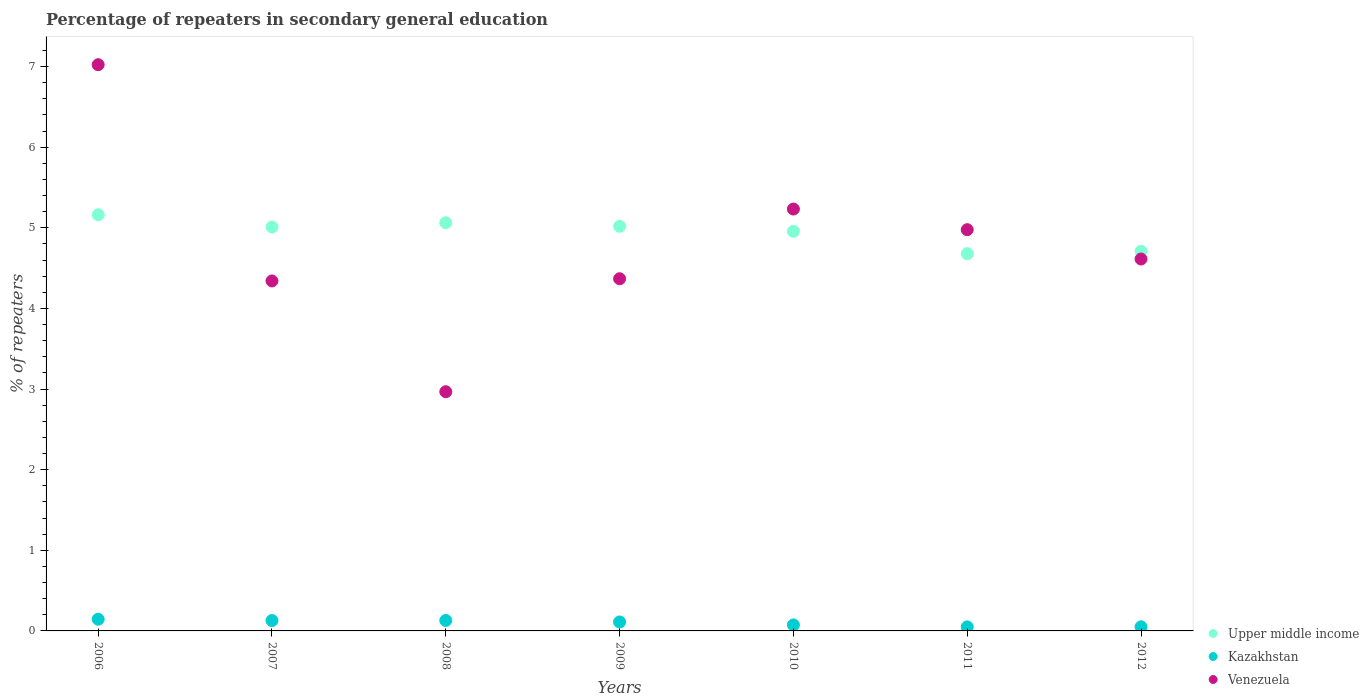Is the number of dotlines equal to the number of legend labels?
Your answer should be compact. Yes. What is the percentage of repeaters in secondary general education in Kazakhstan in 2007?
Ensure brevity in your answer.  0.13. Across all years, what is the maximum percentage of repeaters in secondary general education in Upper middle income?
Offer a very short reply. 5.16. Across all years, what is the minimum percentage of repeaters in secondary general education in Kazakhstan?
Offer a very short reply. 0.05. In which year was the percentage of repeaters in secondary general education in Upper middle income minimum?
Keep it short and to the point. 2011. What is the total percentage of repeaters in secondary general education in Upper middle income in the graph?
Your answer should be very brief. 34.6. What is the difference between the percentage of repeaters in secondary general education in Upper middle income in 2008 and that in 2009?
Offer a very short reply. 0.04. What is the difference between the percentage of repeaters in secondary general education in Venezuela in 2006 and the percentage of repeaters in secondary general education in Upper middle income in 2010?
Offer a terse response. 2.07. What is the average percentage of repeaters in secondary general education in Kazakhstan per year?
Make the answer very short. 0.1. In the year 2006, what is the difference between the percentage of repeaters in secondary general education in Upper middle income and percentage of repeaters in secondary general education in Venezuela?
Your answer should be very brief. -1.86. What is the ratio of the percentage of repeaters in secondary general education in Venezuela in 2009 to that in 2011?
Offer a very short reply. 0.88. What is the difference between the highest and the second highest percentage of repeaters in secondary general education in Venezuela?
Provide a short and direct response. 1.79. What is the difference between the highest and the lowest percentage of repeaters in secondary general education in Upper middle income?
Offer a very short reply. 0.48. In how many years, is the percentage of repeaters in secondary general education in Kazakhstan greater than the average percentage of repeaters in secondary general education in Kazakhstan taken over all years?
Provide a short and direct response. 4. Is it the case that in every year, the sum of the percentage of repeaters in secondary general education in Kazakhstan and percentage of repeaters in secondary general education in Venezuela  is greater than the percentage of repeaters in secondary general education in Upper middle income?
Offer a terse response. No. Is the percentage of repeaters in secondary general education in Venezuela strictly less than the percentage of repeaters in secondary general education in Kazakhstan over the years?
Your answer should be very brief. No. How many dotlines are there?
Ensure brevity in your answer.  3. How many years are there in the graph?
Your answer should be compact. 7. Are the values on the major ticks of Y-axis written in scientific E-notation?
Provide a succinct answer. No. How many legend labels are there?
Your answer should be very brief. 3. How are the legend labels stacked?
Offer a terse response. Vertical. What is the title of the graph?
Make the answer very short. Percentage of repeaters in secondary general education. Does "Marshall Islands" appear as one of the legend labels in the graph?
Make the answer very short. No. What is the label or title of the Y-axis?
Ensure brevity in your answer.  % of repeaters. What is the % of repeaters in Upper middle income in 2006?
Your response must be concise. 5.16. What is the % of repeaters of Kazakhstan in 2006?
Provide a short and direct response. 0.14. What is the % of repeaters in Venezuela in 2006?
Offer a very short reply. 7.02. What is the % of repeaters of Upper middle income in 2007?
Give a very brief answer. 5.01. What is the % of repeaters in Kazakhstan in 2007?
Provide a succinct answer. 0.13. What is the % of repeaters in Venezuela in 2007?
Your response must be concise. 4.34. What is the % of repeaters of Upper middle income in 2008?
Make the answer very short. 5.06. What is the % of repeaters in Kazakhstan in 2008?
Offer a terse response. 0.13. What is the % of repeaters of Venezuela in 2008?
Your response must be concise. 2.97. What is the % of repeaters of Upper middle income in 2009?
Offer a very short reply. 5.02. What is the % of repeaters of Kazakhstan in 2009?
Give a very brief answer. 0.11. What is the % of repeaters of Venezuela in 2009?
Keep it short and to the point. 4.37. What is the % of repeaters in Upper middle income in 2010?
Keep it short and to the point. 4.96. What is the % of repeaters in Kazakhstan in 2010?
Provide a succinct answer. 0.07. What is the % of repeaters in Venezuela in 2010?
Your response must be concise. 5.23. What is the % of repeaters in Upper middle income in 2011?
Ensure brevity in your answer.  4.68. What is the % of repeaters in Kazakhstan in 2011?
Give a very brief answer. 0.05. What is the % of repeaters in Venezuela in 2011?
Keep it short and to the point. 4.98. What is the % of repeaters of Upper middle income in 2012?
Offer a terse response. 4.71. What is the % of repeaters of Kazakhstan in 2012?
Offer a very short reply. 0.05. What is the % of repeaters in Venezuela in 2012?
Your answer should be compact. 4.61. Across all years, what is the maximum % of repeaters of Upper middle income?
Provide a short and direct response. 5.16. Across all years, what is the maximum % of repeaters in Kazakhstan?
Give a very brief answer. 0.14. Across all years, what is the maximum % of repeaters of Venezuela?
Give a very brief answer. 7.02. Across all years, what is the minimum % of repeaters of Upper middle income?
Provide a succinct answer. 4.68. Across all years, what is the minimum % of repeaters of Kazakhstan?
Offer a terse response. 0.05. Across all years, what is the minimum % of repeaters of Venezuela?
Offer a very short reply. 2.97. What is the total % of repeaters of Upper middle income in the graph?
Offer a terse response. 34.6. What is the total % of repeaters in Kazakhstan in the graph?
Ensure brevity in your answer.  0.69. What is the total % of repeaters in Venezuela in the graph?
Keep it short and to the point. 33.52. What is the difference between the % of repeaters in Upper middle income in 2006 and that in 2007?
Provide a short and direct response. 0.15. What is the difference between the % of repeaters in Kazakhstan in 2006 and that in 2007?
Offer a very short reply. 0.02. What is the difference between the % of repeaters of Venezuela in 2006 and that in 2007?
Your answer should be very brief. 2.68. What is the difference between the % of repeaters in Upper middle income in 2006 and that in 2008?
Provide a short and direct response. 0.1. What is the difference between the % of repeaters of Kazakhstan in 2006 and that in 2008?
Your answer should be compact. 0.02. What is the difference between the % of repeaters in Venezuela in 2006 and that in 2008?
Offer a very short reply. 4.06. What is the difference between the % of repeaters of Upper middle income in 2006 and that in 2009?
Make the answer very short. 0.14. What is the difference between the % of repeaters in Kazakhstan in 2006 and that in 2009?
Ensure brevity in your answer.  0.03. What is the difference between the % of repeaters in Venezuela in 2006 and that in 2009?
Provide a succinct answer. 2.66. What is the difference between the % of repeaters of Upper middle income in 2006 and that in 2010?
Your answer should be very brief. 0.21. What is the difference between the % of repeaters in Kazakhstan in 2006 and that in 2010?
Your response must be concise. 0.07. What is the difference between the % of repeaters of Venezuela in 2006 and that in 2010?
Your answer should be very brief. 1.79. What is the difference between the % of repeaters in Upper middle income in 2006 and that in 2011?
Your answer should be very brief. 0.48. What is the difference between the % of repeaters of Kazakhstan in 2006 and that in 2011?
Your answer should be very brief. 0.09. What is the difference between the % of repeaters of Venezuela in 2006 and that in 2011?
Offer a very short reply. 2.05. What is the difference between the % of repeaters of Upper middle income in 2006 and that in 2012?
Give a very brief answer. 0.45. What is the difference between the % of repeaters of Kazakhstan in 2006 and that in 2012?
Give a very brief answer. 0.09. What is the difference between the % of repeaters in Venezuela in 2006 and that in 2012?
Ensure brevity in your answer.  2.41. What is the difference between the % of repeaters in Upper middle income in 2007 and that in 2008?
Provide a short and direct response. -0.05. What is the difference between the % of repeaters of Kazakhstan in 2007 and that in 2008?
Give a very brief answer. -0. What is the difference between the % of repeaters of Venezuela in 2007 and that in 2008?
Keep it short and to the point. 1.37. What is the difference between the % of repeaters of Upper middle income in 2007 and that in 2009?
Keep it short and to the point. -0.01. What is the difference between the % of repeaters in Kazakhstan in 2007 and that in 2009?
Offer a very short reply. 0.02. What is the difference between the % of repeaters of Venezuela in 2007 and that in 2009?
Provide a succinct answer. -0.03. What is the difference between the % of repeaters in Upper middle income in 2007 and that in 2010?
Offer a very short reply. 0.05. What is the difference between the % of repeaters of Kazakhstan in 2007 and that in 2010?
Ensure brevity in your answer.  0.05. What is the difference between the % of repeaters of Venezuela in 2007 and that in 2010?
Offer a terse response. -0.89. What is the difference between the % of repeaters in Upper middle income in 2007 and that in 2011?
Keep it short and to the point. 0.33. What is the difference between the % of repeaters of Kazakhstan in 2007 and that in 2011?
Make the answer very short. 0.08. What is the difference between the % of repeaters in Venezuela in 2007 and that in 2011?
Provide a succinct answer. -0.64. What is the difference between the % of repeaters of Upper middle income in 2007 and that in 2012?
Ensure brevity in your answer.  0.3. What is the difference between the % of repeaters of Kazakhstan in 2007 and that in 2012?
Your answer should be compact. 0.08. What is the difference between the % of repeaters in Venezuela in 2007 and that in 2012?
Your answer should be compact. -0.27. What is the difference between the % of repeaters in Upper middle income in 2008 and that in 2009?
Your answer should be compact. 0.04. What is the difference between the % of repeaters in Kazakhstan in 2008 and that in 2009?
Offer a very short reply. 0.02. What is the difference between the % of repeaters of Venezuela in 2008 and that in 2009?
Give a very brief answer. -1.4. What is the difference between the % of repeaters of Upper middle income in 2008 and that in 2010?
Provide a short and direct response. 0.11. What is the difference between the % of repeaters of Kazakhstan in 2008 and that in 2010?
Provide a succinct answer. 0.06. What is the difference between the % of repeaters of Venezuela in 2008 and that in 2010?
Keep it short and to the point. -2.27. What is the difference between the % of repeaters of Upper middle income in 2008 and that in 2011?
Your response must be concise. 0.38. What is the difference between the % of repeaters in Kazakhstan in 2008 and that in 2011?
Offer a terse response. 0.08. What is the difference between the % of repeaters in Venezuela in 2008 and that in 2011?
Give a very brief answer. -2.01. What is the difference between the % of repeaters of Upper middle income in 2008 and that in 2012?
Provide a short and direct response. 0.35. What is the difference between the % of repeaters in Kazakhstan in 2008 and that in 2012?
Your response must be concise. 0.08. What is the difference between the % of repeaters of Venezuela in 2008 and that in 2012?
Your answer should be very brief. -1.65. What is the difference between the % of repeaters of Upper middle income in 2009 and that in 2010?
Offer a very short reply. 0.06. What is the difference between the % of repeaters of Kazakhstan in 2009 and that in 2010?
Offer a terse response. 0.04. What is the difference between the % of repeaters of Venezuela in 2009 and that in 2010?
Offer a very short reply. -0.86. What is the difference between the % of repeaters of Upper middle income in 2009 and that in 2011?
Your answer should be very brief. 0.34. What is the difference between the % of repeaters in Kazakhstan in 2009 and that in 2011?
Keep it short and to the point. 0.06. What is the difference between the % of repeaters in Venezuela in 2009 and that in 2011?
Ensure brevity in your answer.  -0.61. What is the difference between the % of repeaters of Upper middle income in 2009 and that in 2012?
Provide a short and direct response. 0.31. What is the difference between the % of repeaters in Kazakhstan in 2009 and that in 2012?
Provide a succinct answer. 0.06. What is the difference between the % of repeaters in Venezuela in 2009 and that in 2012?
Provide a short and direct response. -0.24. What is the difference between the % of repeaters of Upper middle income in 2010 and that in 2011?
Your answer should be very brief. 0.28. What is the difference between the % of repeaters in Kazakhstan in 2010 and that in 2011?
Provide a short and direct response. 0.02. What is the difference between the % of repeaters of Venezuela in 2010 and that in 2011?
Offer a very short reply. 0.26. What is the difference between the % of repeaters in Upper middle income in 2010 and that in 2012?
Offer a terse response. 0.25. What is the difference between the % of repeaters in Kazakhstan in 2010 and that in 2012?
Offer a very short reply. 0.02. What is the difference between the % of repeaters in Venezuela in 2010 and that in 2012?
Keep it short and to the point. 0.62. What is the difference between the % of repeaters of Upper middle income in 2011 and that in 2012?
Your answer should be compact. -0.03. What is the difference between the % of repeaters of Kazakhstan in 2011 and that in 2012?
Your answer should be very brief. -0. What is the difference between the % of repeaters in Venezuela in 2011 and that in 2012?
Your answer should be very brief. 0.36. What is the difference between the % of repeaters in Upper middle income in 2006 and the % of repeaters in Kazakhstan in 2007?
Your answer should be very brief. 5.03. What is the difference between the % of repeaters in Upper middle income in 2006 and the % of repeaters in Venezuela in 2007?
Make the answer very short. 0.82. What is the difference between the % of repeaters in Kazakhstan in 2006 and the % of repeaters in Venezuela in 2007?
Give a very brief answer. -4.2. What is the difference between the % of repeaters of Upper middle income in 2006 and the % of repeaters of Kazakhstan in 2008?
Your answer should be compact. 5.03. What is the difference between the % of repeaters in Upper middle income in 2006 and the % of repeaters in Venezuela in 2008?
Make the answer very short. 2.2. What is the difference between the % of repeaters of Kazakhstan in 2006 and the % of repeaters of Venezuela in 2008?
Ensure brevity in your answer.  -2.82. What is the difference between the % of repeaters in Upper middle income in 2006 and the % of repeaters in Kazakhstan in 2009?
Offer a very short reply. 5.05. What is the difference between the % of repeaters in Upper middle income in 2006 and the % of repeaters in Venezuela in 2009?
Keep it short and to the point. 0.79. What is the difference between the % of repeaters in Kazakhstan in 2006 and the % of repeaters in Venezuela in 2009?
Make the answer very short. -4.22. What is the difference between the % of repeaters of Upper middle income in 2006 and the % of repeaters of Kazakhstan in 2010?
Ensure brevity in your answer.  5.09. What is the difference between the % of repeaters of Upper middle income in 2006 and the % of repeaters of Venezuela in 2010?
Provide a short and direct response. -0.07. What is the difference between the % of repeaters in Kazakhstan in 2006 and the % of repeaters in Venezuela in 2010?
Provide a succinct answer. -5.09. What is the difference between the % of repeaters in Upper middle income in 2006 and the % of repeaters in Kazakhstan in 2011?
Your answer should be compact. 5.11. What is the difference between the % of repeaters of Upper middle income in 2006 and the % of repeaters of Venezuela in 2011?
Your response must be concise. 0.19. What is the difference between the % of repeaters in Kazakhstan in 2006 and the % of repeaters in Venezuela in 2011?
Your answer should be very brief. -4.83. What is the difference between the % of repeaters in Upper middle income in 2006 and the % of repeaters in Kazakhstan in 2012?
Your response must be concise. 5.11. What is the difference between the % of repeaters of Upper middle income in 2006 and the % of repeaters of Venezuela in 2012?
Keep it short and to the point. 0.55. What is the difference between the % of repeaters in Kazakhstan in 2006 and the % of repeaters in Venezuela in 2012?
Keep it short and to the point. -4.47. What is the difference between the % of repeaters of Upper middle income in 2007 and the % of repeaters of Kazakhstan in 2008?
Keep it short and to the point. 4.88. What is the difference between the % of repeaters of Upper middle income in 2007 and the % of repeaters of Venezuela in 2008?
Offer a very short reply. 2.04. What is the difference between the % of repeaters in Kazakhstan in 2007 and the % of repeaters in Venezuela in 2008?
Keep it short and to the point. -2.84. What is the difference between the % of repeaters of Upper middle income in 2007 and the % of repeaters of Kazakhstan in 2009?
Provide a succinct answer. 4.9. What is the difference between the % of repeaters of Upper middle income in 2007 and the % of repeaters of Venezuela in 2009?
Ensure brevity in your answer.  0.64. What is the difference between the % of repeaters of Kazakhstan in 2007 and the % of repeaters of Venezuela in 2009?
Offer a very short reply. -4.24. What is the difference between the % of repeaters in Upper middle income in 2007 and the % of repeaters in Kazakhstan in 2010?
Make the answer very short. 4.94. What is the difference between the % of repeaters in Upper middle income in 2007 and the % of repeaters in Venezuela in 2010?
Keep it short and to the point. -0.22. What is the difference between the % of repeaters in Kazakhstan in 2007 and the % of repeaters in Venezuela in 2010?
Offer a terse response. -5.1. What is the difference between the % of repeaters of Upper middle income in 2007 and the % of repeaters of Kazakhstan in 2011?
Keep it short and to the point. 4.96. What is the difference between the % of repeaters of Kazakhstan in 2007 and the % of repeaters of Venezuela in 2011?
Provide a short and direct response. -4.85. What is the difference between the % of repeaters in Upper middle income in 2007 and the % of repeaters in Kazakhstan in 2012?
Keep it short and to the point. 4.96. What is the difference between the % of repeaters in Upper middle income in 2007 and the % of repeaters in Venezuela in 2012?
Give a very brief answer. 0.4. What is the difference between the % of repeaters in Kazakhstan in 2007 and the % of repeaters in Venezuela in 2012?
Keep it short and to the point. -4.48. What is the difference between the % of repeaters in Upper middle income in 2008 and the % of repeaters in Kazakhstan in 2009?
Ensure brevity in your answer.  4.95. What is the difference between the % of repeaters in Upper middle income in 2008 and the % of repeaters in Venezuela in 2009?
Your response must be concise. 0.69. What is the difference between the % of repeaters in Kazakhstan in 2008 and the % of repeaters in Venezuela in 2009?
Your answer should be compact. -4.24. What is the difference between the % of repeaters in Upper middle income in 2008 and the % of repeaters in Kazakhstan in 2010?
Provide a succinct answer. 4.99. What is the difference between the % of repeaters in Upper middle income in 2008 and the % of repeaters in Venezuela in 2010?
Provide a short and direct response. -0.17. What is the difference between the % of repeaters in Kazakhstan in 2008 and the % of repeaters in Venezuela in 2010?
Your answer should be compact. -5.1. What is the difference between the % of repeaters of Upper middle income in 2008 and the % of repeaters of Kazakhstan in 2011?
Your answer should be compact. 5.01. What is the difference between the % of repeaters in Upper middle income in 2008 and the % of repeaters in Venezuela in 2011?
Offer a terse response. 0.09. What is the difference between the % of repeaters of Kazakhstan in 2008 and the % of repeaters of Venezuela in 2011?
Your answer should be very brief. -4.85. What is the difference between the % of repeaters of Upper middle income in 2008 and the % of repeaters of Kazakhstan in 2012?
Make the answer very short. 5.01. What is the difference between the % of repeaters in Upper middle income in 2008 and the % of repeaters in Venezuela in 2012?
Make the answer very short. 0.45. What is the difference between the % of repeaters of Kazakhstan in 2008 and the % of repeaters of Venezuela in 2012?
Provide a succinct answer. -4.48. What is the difference between the % of repeaters of Upper middle income in 2009 and the % of repeaters of Kazakhstan in 2010?
Your answer should be compact. 4.94. What is the difference between the % of repeaters of Upper middle income in 2009 and the % of repeaters of Venezuela in 2010?
Provide a short and direct response. -0.21. What is the difference between the % of repeaters in Kazakhstan in 2009 and the % of repeaters in Venezuela in 2010?
Make the answer very short. -5.12. What is the difference between the % of repeaters of Upper middle income in 2009 and the % of repeaters of Kazakhstan in 2011?
Give a very brief answer. 4.97. What is the difference between the % of repeaters of Upper middle income in 2009 and the % of repeaters of Venezuela in 2011?
Make the answer very short. 0.04. What is the difference between the % of repeaters in Kazakhstan in 2009 and the % of repeaters in Venezuela in 2011?
Offer a very short reply. -4.87. What is the difference between the % of repeaters in Upper middle income in 2009 and the % of repeaters in Kazakhstan in 2012?
Make the answer very short. 4.97. What is the difference between the % of repeaters in Upper middle income in 2009 and the % of repeaters in Venezuela in 2012?
Your answer should be very brief. 0.41. What is the difference between the % of repeaters of Kazakhstan in 2009 and the % of repeaters of Venezuela in 2012?
Provide a short and direct response. -4.5. What is the difference between the % of repeaters in Upper middle income in 2010 and the % of repeaters in Kazakhstan in 2011?
Provide a succinct answer. 4.91. What is the difference between the % of repeaters of Upper middle income in 2010 and the % of repeaters of Venezuela in 2011?
Offer a very short reply. -0.02. What is the difference between the % of repeaters in Kazakhstan in 2010 and the % of repeaters in Venezuela in 2011?
Make the answer very short. -4.9. What is the difference between the % of repeaters of Upper middle income in 2010 and the % of repeaters of Kazakhstan in 2012?
Provide a succinct answer. 4.91. What is the difference between the % of repeaters of Upper middle income in 2010 and the % of repeaters of Venezuela in 2012?
Make the answer very short. 0.34. What is the difference between the % of repeaters of Kazakhstan in 2010 and the % of repeaters of Venezuela in 2012?
Offer a very short reply. -4.54. What is the difference between the % of repeaters in Upper middle income in 2011 and the % of repeaters in Kazakhstan in 2012?
Ensure brevity in your answer.  4.63. What is the difference between the % of repeaters in Upper middle income in 2011 and the % of repeaters in Venezuela in 2012?
Give a very brief answer. 0.07. What is the difference between the % of repeaters in Kazakhstan in 2011 and the % of repeaters in Venezuela in 2012?
Your answer should be very brief. -4.56. What is the average % of repeaters of Upper middle income per year?
Provide a succinct answer. 4.94. What is the average % of repeaters of Kazakhstan per year?
Provide a short and direct response. 0.1. What is the average % of repeaters of Venezuela per year?
Provide a succinct answer. 4.79. In the year 2006, what is the difference between the % of repeaters of Upper middle income and % of repeaters of Kazakhstan?
Offer a terse response. 5.02. In the year 2006, what is the difference between the % of repeaters in Upper middle income and % of repeaters in Venezuela?
Your answer should be compact. -1.86. In the year 2006, what is the difference between the % of repeaters in Kazakhstan and % of repeaters in Venezuela?
Provide a short and direct response. -6.88. In the year 2007, what is the difference between the % of repeaters of Upper middle income and % of repeaters of Kazakhstan?
Give a very brief answer. 4.88. In the year 2007, what is the difference between the % of repeaters in Upper middle income and % of repeaters in Venezuela?
Your answer should be compact. 0.67. In the year 2007, what is the difference between the % of repeaters of Kazakhstan and % of repeaters of Venezuela?
Offer a terse response. -4.21. In the year 2008, what is the difference between the % of repeaters of Upper middle income and % of repeaters of Kazakhstan?
Your answer should be compact. 4.93. In the year 2008, what is the difference between the % of repeaters of Upper middle income and % of repeaters of Venezuela?
Offer a very short reply. 2.1. In the year 2008, what is the difference between the % of repeaters in Kazakhstan and % of repeaters in Venezuela?
Offer a terse response. -2.84. In the year 2009, what is the difference between the % of repeaters in Upper middle income and % of repeaters in Kazakhstan?
Offer a very short reply. 4.91. In the year 2009, what is the difference between the % of repeaters of Upper middle income and % of repeaters of Venezuela?
Offer a terse response. 0.65. In the year 2009, what is the difference between the % of repeaters of Kazakhstan and % of repeaters of Venezuela?
Your response must be concise. -4.26. In the year 2010, what is the difference between the % of repeaters of Upper middle income and % of repeaters of Kazakhstan?
Give a very brief answer. 4.88. In the year 2010, what is the difference between the % of repeaters in Upper middle income and % of repeaters in Venezuela?
Offer a very short reply. -0.28. In the year 2010, what is the difference between the % of repeaters in Kazakhstan and % of repeaters in Venezuela?
Your response must be concise. -5.16. In the year 2011, what is the difference between the % of repeaters of Upper middle income and % of repeaters of Kazakhstan?
Your answer should be compact. 4.63. In the year 2011, what is the difference between the % of repeaters of Upper middle income and % of repeaters of Venezuela?
Your answer should be very brief. -0.3. In the year 2011, what is the difference between the % of repeaters of Kazakhstan and % of repeaters of Venezuela?
Offer a terse response. -4.93. In the year 2012, what is the difference between the % of repeaters of Upper middle income and % of repeaters of Kazakhstan?
Make the answer very short. 4.66. In the year 2012, what is the difference between the % of repeaters in Upper middle income and % of repeaters in Venezuela?
Provide a succinct answer. 0.1. In the year 2012, what is the difference between the % of repeaters of Kazakhstan and % of repeaters of Venezuela?
Your answer should be very brief. -4.56. What is the ratio of the % of repeaters in Upper middle income in 2006 to that in 2007?
Offer a terse response. 1.03. What is the ratio of the % of repeaters in Kazakhstan in 2006 to that in 2007?
Offer a very short reply. 1.13. What is the ratio of the % of repeaters of Venezuela in 2006 to that in 2007?
Offer a very short reply. 1.62. What is the ratio of the % of repeaters in Upper middle income in 2006 to that in 2008?
Provide a succinct answer. 1.02. What is the ratio of the % of repeaters in Kazakhstan in 2006 to that in 2008?
Your answer should be very brief. 1.12. What is the ratio of the % of repeaters in Venezuela in 2006 to that in 2008?
Offer a terse response. 2.37. What is the ratio of the % of repeaters of Upper middle income in 2006 to that in 2009?
Your response must be concise. 1.03. What is the ratio of the % of repeaters of Kazakhstan in 2006 to that in 2009?
Make the answer very short. 1.31. What is the ratio of the % of repeaters in Venezuela in 2006 to that in 2009?
Offer a very short reply. 1.61. What is the ratio of the % of repeaters of Upper middle income in 2006 to that in 2010?
Ensure brevity in your answer.  1.04. What is the ratio of the % of repeaters of Kazakhstan in 2006 to that in 2010?
Give a very brief answer. 1.95. What is the ratio of the % of repeaters of Venezuela in 2006 to that in 2010?
Your response must be concise. 1.34. What is the ratio of the % of repeaters of Upper middle income in 2006 to that in 2011?
Offer a very short reply. 1.1. What is the ratio of the % of repeaters in Kazakhstan in 2006 to that in 2011?
Ensure brevity in your answer.  2.89. What is the ratio of the % of repeaters in Venezuela in 2006 to that in 2011?
Make the answer very short. 1.41. What is the ratio of the % of repeaters in Upper middle income in 2006 to that in 2012?
Offer a terse response. 1.1. What is the ratio of the % of repeaters in Kazakhstan in 2006 to that in 2012?
Your response must be concise. 2.84. What is the ratio of the % of repeaters of Venezuela in 2006 to that in 2012?
Offer a very short reply. 1.52. What is the ratio of the % of repeaters of Kazakhstan in 2007 to that in 2008?
Give a very brief answer. 0.99. What is the ratio of the % of repeaters of Venezuela in 2007 to that in 2008?
Provide a short and direct response. 1.46. What is the ratio of the % of repeaters of Upper middle income in 2007 to that in 2009?
Offer a terse response. 1. What is the ratio of the % of repeaters of Kazakhstan in 2007 to that in 2009?
Provide a short and direct response. 1.16. What is the ratio of the % of repeaters in Upper middle income in 2007 to that in 2010?
Keep it short and to the point. 1.01. What is the ratio of the % of repeaters of Kazakhstan in 2007 to that in 2010?
Your answer should be very brief. 1.73. What is the ratio of the % of repeaters in Venezuela in 2007 to that in 2010?
Your answer should be very brief. 0.83. What is the ratio of the % of repeaters of Upper middle income in 2007 to that in 2011?
Provide a short and direct response. 1.07. What is the ratio of the % of repeaters in Kazakhstan in 2007 to that in 2011?
Ensure brevity in your answer.  2.57. What is the ratio of the % of repeaters of Venezuela in 2007 to that in 2011?
Your response must be concise. 0.87. What is the ratio of the % of repeaters in Upper middle income in 2007 to that in 2012?
Keep it short and to the point. 1.06. What is the ratio of the % of repeaters in Kazakhstan in 2007 to that in 2012?
Provide a succinct answer. 2.52. What is the ratio of the % of repeaters of Venezuela in 2007 to that in 2012?
Offer a very short reply. 0.94. What is the ratio of the % of repeaters of Upper middle income in 2008 to that in 2009?
Provide a short and direct response. 1.01. What is the ratio of the % of repeaters in Kazakhstan in 2008 to that in 2009?
Ensure brevity in your answer.  1.17. What is the ratio of the % of repeaters of Venezuela in 2008 to that in 2009?
Offer a very short reply. 0.68. What is the ratio of the % of repeaters of Upper middle income in 2008 to that in 2010?
Give a very brief answer. 1.02. What is the ratio of the % of repeaters of Kazakhstan in 2008 to that in 2010?
Your answer should be compact. 1.74. What is the ratio of the % of repeaters in Venezuela in 2008 to that in 2010?
Your response must be concise. 0.57. What is the ratio of the % of repeaters in Upper middle income in 2008 to that in 2011?
Offer a very short reply. 1.08. What is the ratio of the % of repeaters of Kazakhstan in 2008 to that in 2011?
Your response must be concise. 2.59. What is the ratio of the % of repeaters in Venezuela in 2008 to that in 2011?
Provide a short and direct response. 0.6. What is the ratio of the % of repeaters in Upper middle income in 2008 to that in 2012?
Your answer should be very brief. 1.08. What is the ratio of the % of repeaters of Kazakhstan in 2008 to that in 2012?
Provide a short and direct response. 2.54. What is the ratio of the % of repeaters of Venezuela in 2008 to that in 2012?
Keep it short and to the point. 0.64. What is the ratio of the % of repeaters in Upper middle income in 2009 to that in 2010?
Make the answer very short. 1.01. What is the ratio of the % of repeaters in Kazakhstan in 2009 to that in 2010?
Provide a short and direct response. 1.49. What is the ratio of the % of repeaters of Venezuela in 2009 to that in 2010?
Your answer should be very brief. 0.83. What is the ratio of the % of repeaters in Upper middle income in 2009 to that in 2011?
Offer a very short reply. 1.07. What is the ratio of the % of repeaters of Kazakhstan in 2009 to that in 2011?
Offer a terse response. 2.21. What is the ratio of the % of repeaters in Venezuela in 2009 to that in 2011?
Your response must be concise. 0.88. What is the ratio of the % of repeaters in Upper middle income in 2009 to that in 2012?
Provide a short and direct response. 1.07. What is the ratio of the % of repeaters of Kazakhstan in 2009 to that in 2012?
Provide a short and direct response. 2.17. What is the ratio of the % of repeaters in Venezuela in 2009 to that in 2012?
Your answer should be compact. 0.95. What is the ratio of the % of repeaters of Upper middle income in 2010 to that in 2011?
Give a very brief answer. 1.06. What is the ratio of the % of repeaters of Kazakhstan in 2010 to that in 2011?
Make the answer very short. 1.48. What is the ratio of the % of repeaters in Venezuela in 2010 to that in 2011?
Keep it short and to the point. 1.05. What is the ratio of the % of repeaters in Upper middle income in 2010 to that in 2012?
Your response must be concise. 1.05. What is the ratio of the % of repeaters in Kazakhstan in 2010 to that in 2012?
Your response must be concise. 1.46. What is the ratio of the % of repeaters of Venezuela in 2010 to that in 2012?
Offer a very short reply. 1.13. What is the ratio of the % of repeaters in Upper middle income in 2011 to that in 2012?
Your answer should be very brief. 0.99. What is the ratio of the % of repeaters of Kazakhstan in 2011 to that in 2012?
Give a very brief answer. 0.98. What is the ratio of the % of repeaters in Venezuela in 2011 to that in 2012?
Give a very brief answer. 1.08. What is the difference between the highest and the second highest % of repeaters of Upper middle income?
Your answer should be very brief. 0.1. What is the difference between the highest and the second highest % of repeaters of Kazakhstan?
Your answer should be very brief. 0.02. What is the difference between the highest and the second highest % of repeaters of Venezuela?
Ensure brevity in your answer.  1.79. What is the difference between the highest and the lowest % of repeaters in Upper middle income?
Provide a succinct answer. 0.48. What is the difference between the highest and the lowest % of repeaters in Kazakhstan?
Make the answer very short. 0.09. What is the difference between the highest and the lowest % of repeaters of Venezuela?
Ensure brevity in your answer.  4.06. 